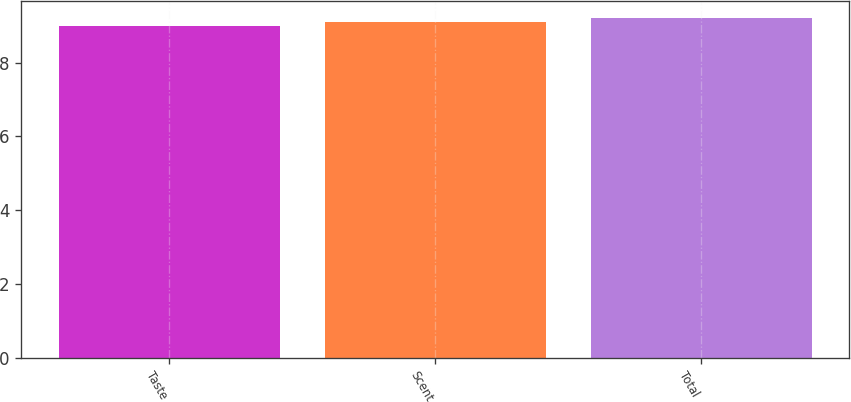Convert chart to OTSL. <chart><loc_0><loc_0><loc_500><loc_500><bar_chart><fcel>Taste<fcel>Scent<fcel>Total<nl><fcel>9<fcel>9.1<fcel>9.2<nl></chart> 